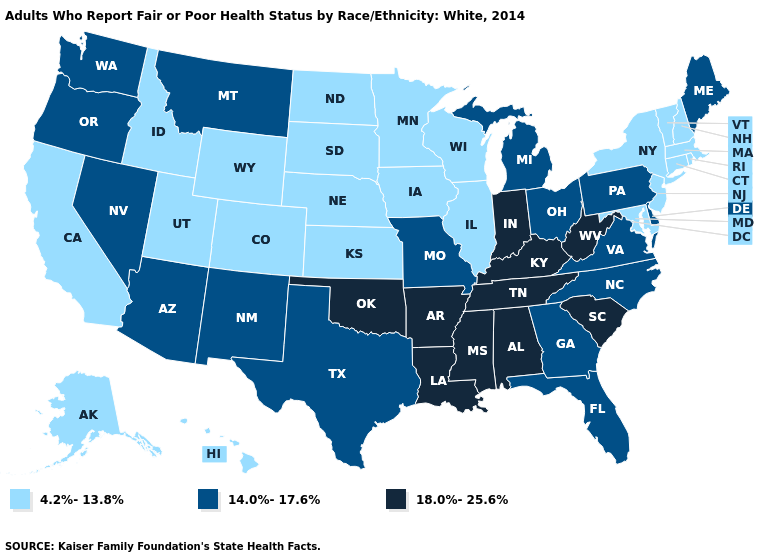Name the states that have a value in the range 18.0%-25.6%?
Short answer required. Alabama, Arkansas, Indiana, Kentucky, Louisiana, Mississippi, Oklahoma, South Carolina, Tennessee, West Virginia. Among the states that border Utah , does Idaho have the highest value?
Quick response, please. No. Which states have the lowest value in the USA?
Write a very short answer. Alaska, California, Colorado, Connecticut, Hawaii, Idaho, Illinois, Iowa, Kansas, Maryland, Massachusetts, Minnesota, Nebraska, New Hampshire, New Jersey, New York, North Dakota, Rhode Island, South Dakota, Utah, Vermont, Wisconsin, Wyoming. Does the first symbol in the legend represent the smallest category?
Quick response, please. Yes. What is the value of Tennessee?
Short answer required. 18.0%-25.6%. Which states hav the highest value in the South?
Answer briefly. Alabama, Arkansas, Kentucky, Louisiana, Mississippi, Oklahoma, South Carolina, Tennessee, West Virginia. What is the value of Arkansas?
Answer briefly. 18.0%-25.6%. What is the value of Utah?
Keep it brief. 4.2%-13.8%. Which states have the highest value in the USA?
Be succinct. Alabama, Arkansas, Indiana, Kentucky, Louisiana, Mississippi, Oklahoma, South Carolina, Tennessee, West Virginia. What is the lowest value in states that border Colorado?
Quick response, please. 4.2%-13.8%. Does the map have missing data?
Quick response, please. No. Does the first symbol in the legend represent the smallest category?
Quick response, please. Yes. What is the highest value in the USA?
Keep it brief. 18.0%-25.6%. Name the states that have a value in the range 14.0%-17.6%?
Answer briefly. Arizona, Delaware, Florida, Georgia, Maine, Michigan, Missouri, Montana, Nevada, New Mexico, North Carolina, Ohio, Oregon, Pennsylvania, Texas, Virginia, Washington. Among the states that border Connecticut , which have the highest value?
Short answer required. Massachusetts, New York, Rhode Island. 